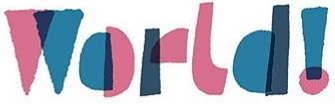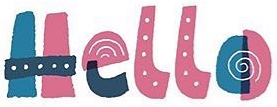What text is displayed in these images sequentially, separated by a semicolon? World!; Hello 